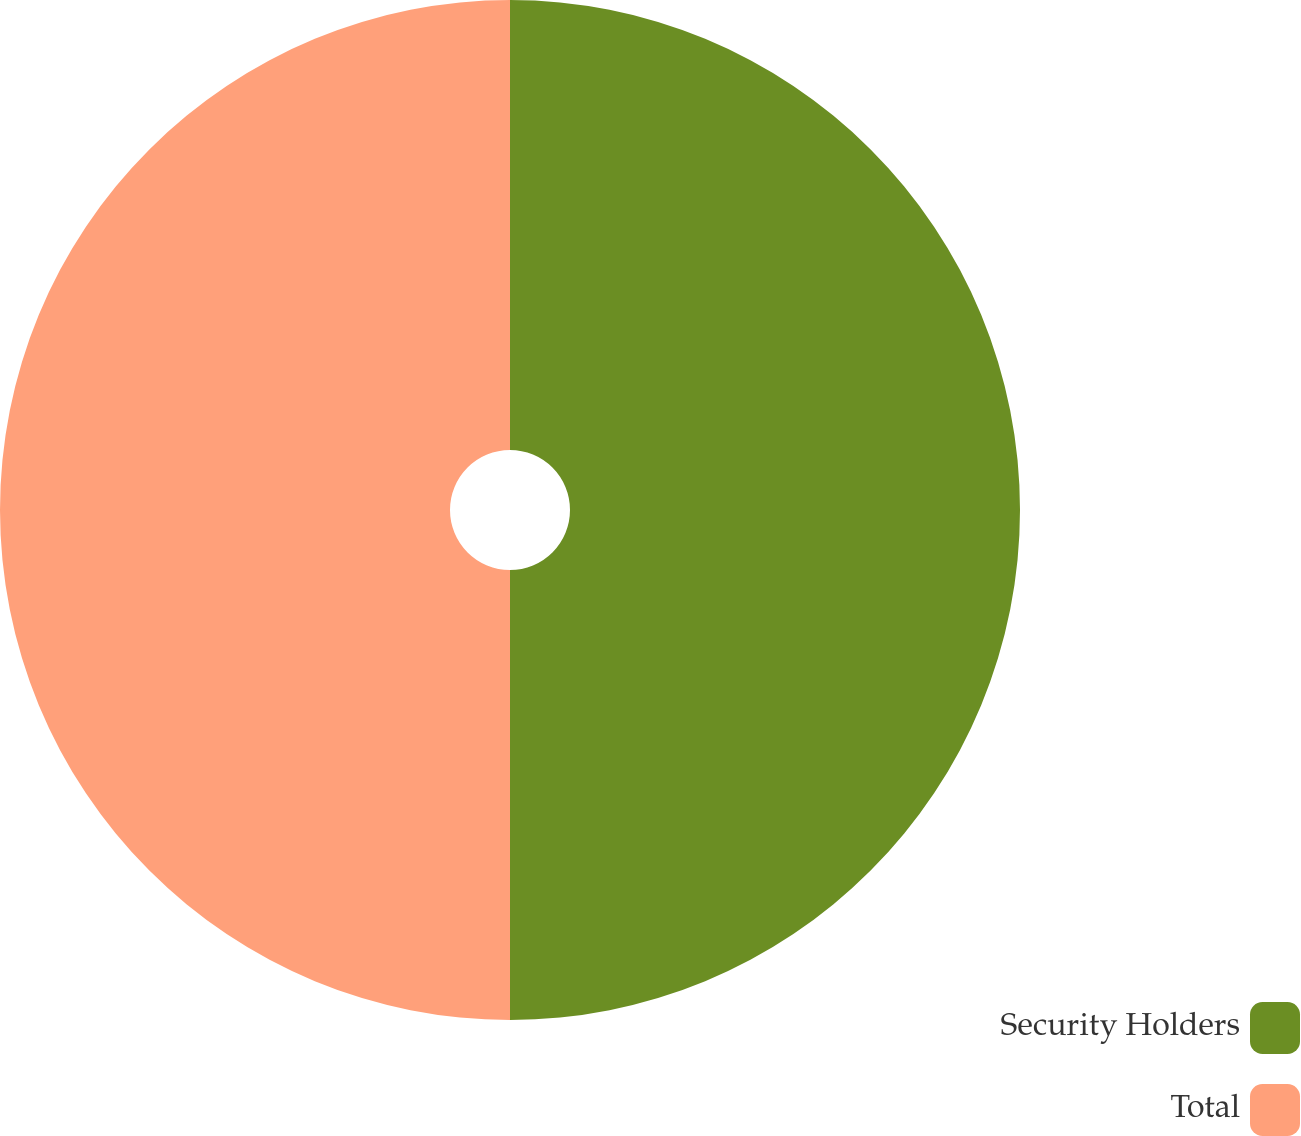Convert chart. <chart><loc_0><loc_0><loc_500><loc_500><pie_chart><fcel>Security Holders<fcel>Total<nl><fcel>50.0%<fcel>50.0%<nl></chart> 